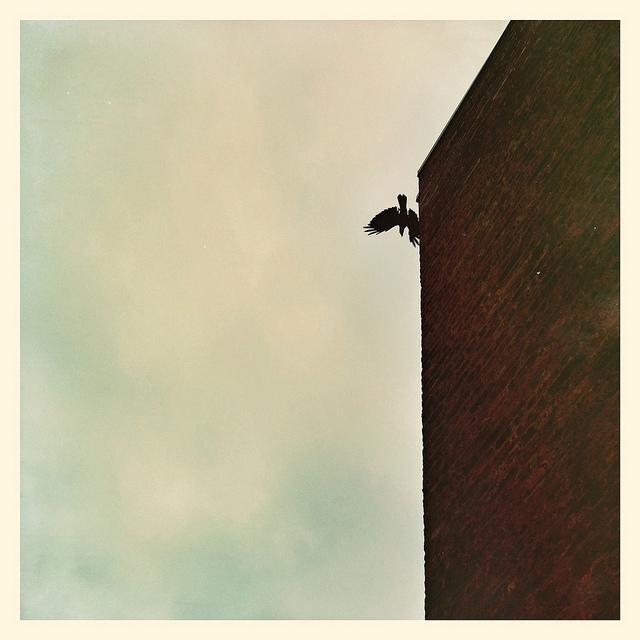How many wheels does the skateboard have?
Give a very brief answer. 0. 